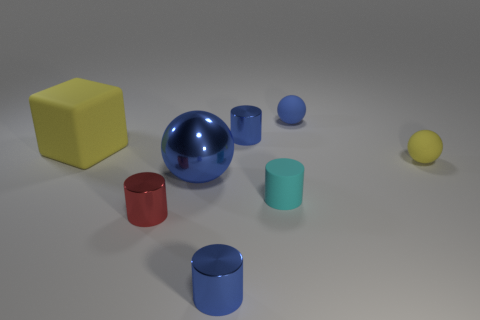Add 2 red metallic things. How many objects exist? 10 Subtract all blocks. How many objects are left? 7 Subtract all tiny red metallic cylinders. Subtract all blue spheres. How many objects are left? 5 Add 6 small yellow matte spheres. How many small yellow matte spheres are left? 7 Add 1 small blue things. How many small blue things exist? 4 Subtract 1 red cylinders. How many objects are left? 7 